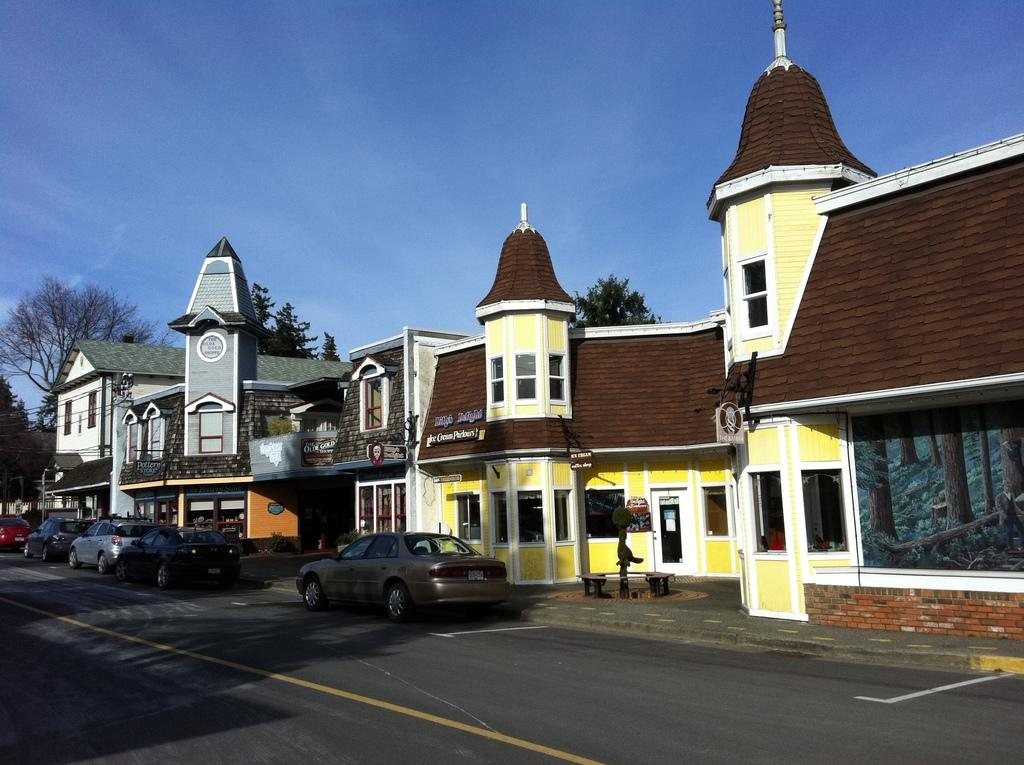What type of structures are located in the center of the image? There are houses in the center of the image. What else can be seen in the image besides houses? There are vehicles, boards, trees, and objects visible in the image. What is the surface at the bottom of the image? There is a road at the bottom of the image. What is visible at the top of the image? The sky is visible at the top of the image. What type of oven is being used by the minister in the image? There is no oven or minister present in the image. 